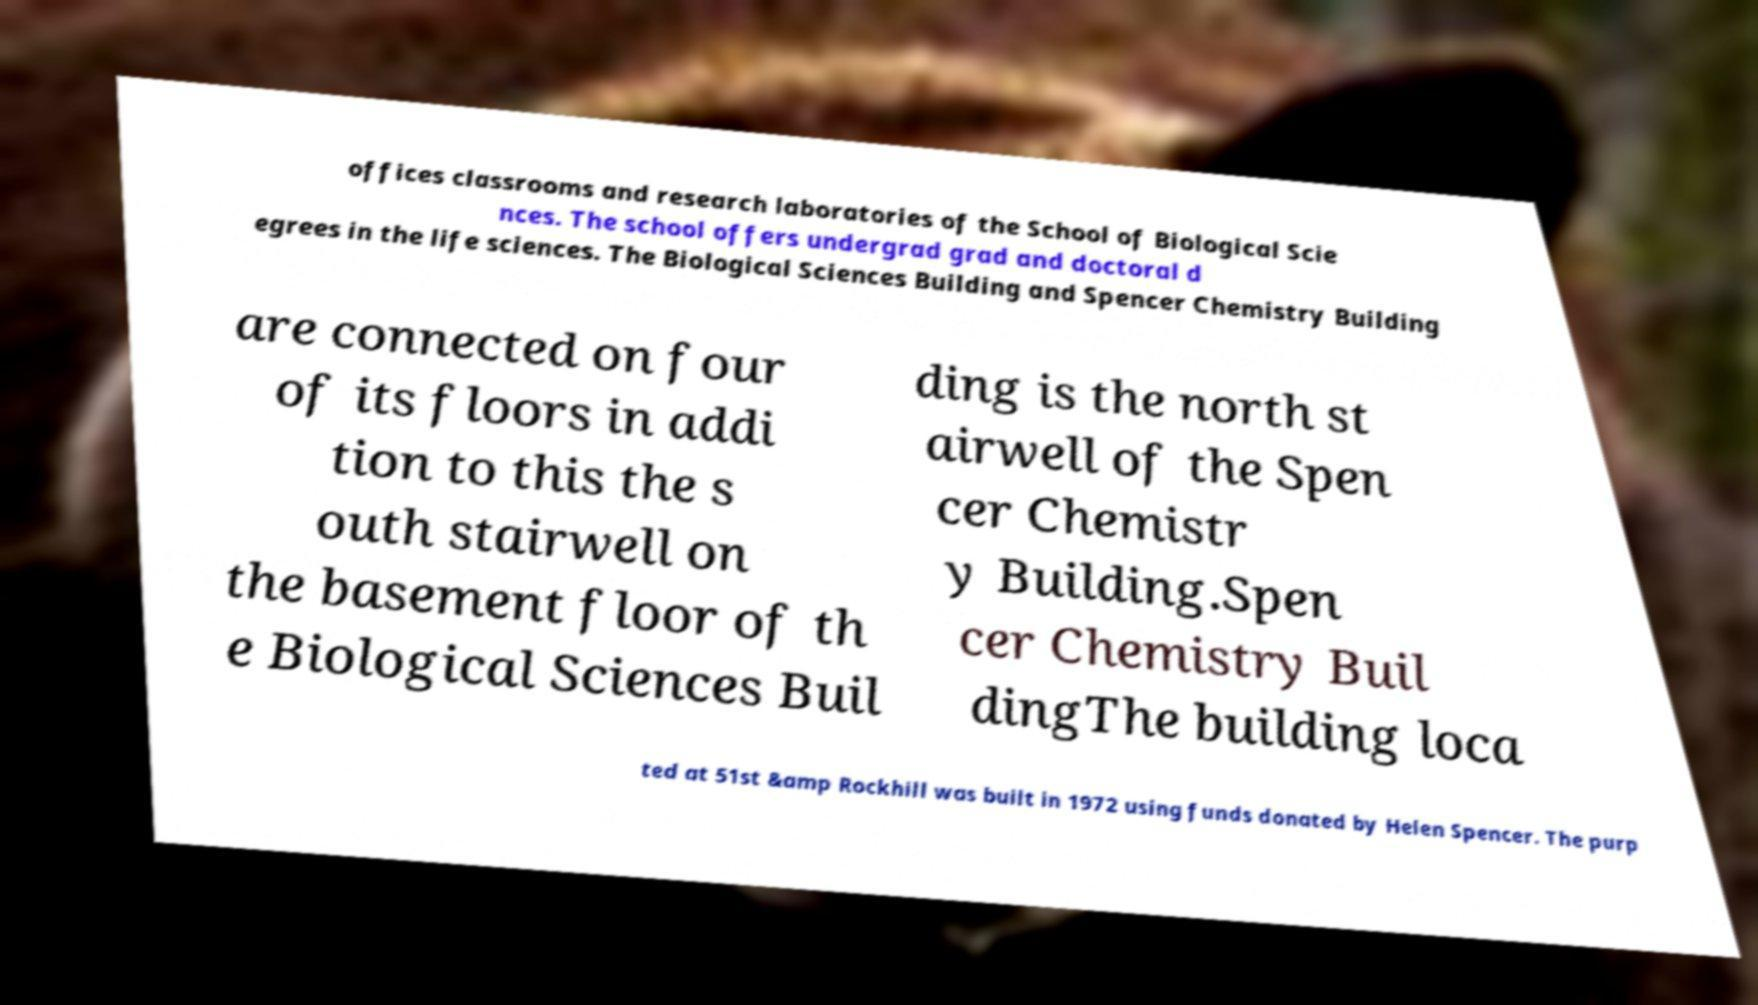For documentation purposes, I need the text within this image transcribed. Could you provide that? offices classrooms and research laboratories of the School of Biological Scie nces. The school offers undergrad grad and doctoral d egrees in the life sciences. The Biological Sciences Building and Spencer Chemistry Building are connected on four of its floors in addi tion to this the s outh stairwell on the basement floor of th e Biological Sciences Buil ding is the north st airwell of the Spen cer Chemistr y Building.Spen cer Chemistry Buil dingThe building loca ted at 51st &amp Rockhill was built in 1972 using funds donated by Helen Spencer. The purp 